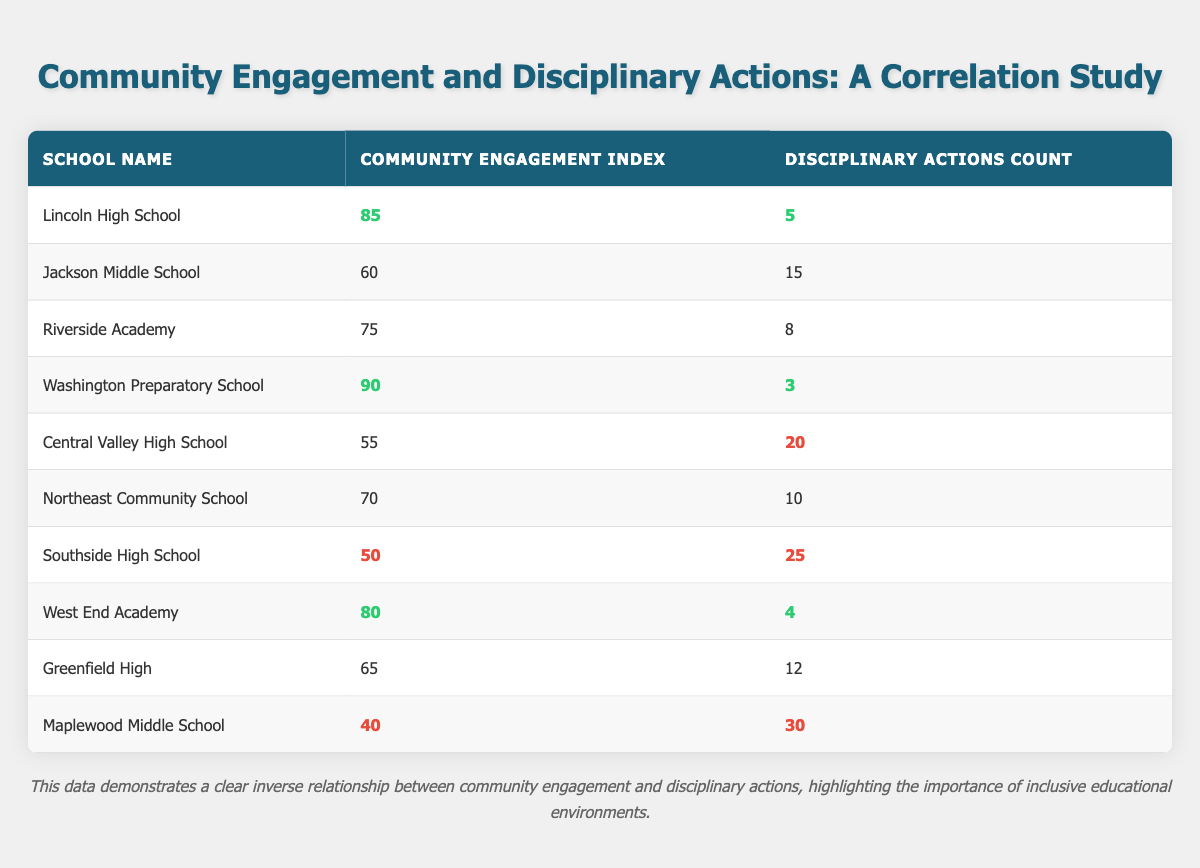What is the community engagement index of Washington Preparatory School? The table shows that Washington Preparatory School has a community engagement index of 90.
Answer: 90 Which school has the highest number of disciplinary actions? By examining the disciplinary actions count column, Maplewood Middle School has the highest count at 30.
Answer: 30 What is the average community engagement index of the schools listed? To find the average, sum the community engagement indexes (85 + 60 + 75 + 90 + 55 + 70 + 50 + 80 + 65 + 40 = 820). There are 10 schools, so the average is 820 divided by 10, which equals 82.
Answer: 82 Does Lincoln High School have a lower count of disciplinary actions than Southside High School? Lincoln High School has a disciplinary actions count of 5, while Southside High School has 25. Since 5 is less than 25, the answer is yes.
Answer: Yes What is the difference in disciplinary actions between Central Valley High School and Riverside Academy? Central Valley High School has 20 disciplinary actions and Riverside Academy has 8. To find the difference, subtract 8 from 20, resulting in 12.
Answer: 12 Which school has a high community engagement index but a low count of disciplinary actions? Both Washington Preparatory School (90, 3 disciplinary actions) and Lincoln High School (85, 5 disciplinary actions) have high community engagement indexes and low disciplinary actions.
Answer: Washington Preparatory School, Lincoln High School What is the total number of disciplinary actions across all schools? To find this total, sum the disciplinary actions counts: (5 + 15 + 8 + 3 + 20 + 10 + 25 + 4 + 12 + 30 = 132). Thus, the total count is 132.
Answer: 132 Is there a school with a community engagement index below 50? Yes, Southside High School has a community engagement index of 50, and Maplewood Middle School has an even lower index of 40.
Answer: Yes Rank the schools based on their community engagement index from highest to lowest, and identify which school ranks second. The ordered list according to the community engagement index is Washington Preparatory School (90), Lincoln High School (85), West End Academy (80), Riverside Academy (75), Northeast Community School (70), Greenfield High (65), Jackson Middle School (60), Central Valley High School (55), Southside High School (50), and Maplewood Middle School (40). The second-ranked school is Lincoln High School.
Answer: Lincoln High School 